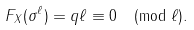<formula> <loc_0><loc_0><loc_500><loc_500>F _ { X } ( \sigma ^ { \ell } ) = q \ell \equiv 0 \pmod { \ell } .</formula> 